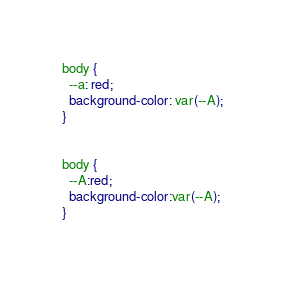<code> <loc_0><loc_0><loc_500><loc_500><_CSS_>body {
  --a: red;
  background-color: var(--A);
}


body {
  --A:red;
  background-color:var(--A);
}
</code> 